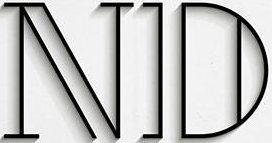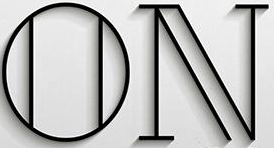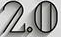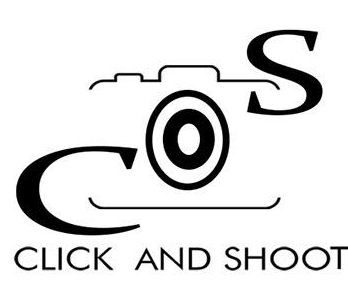What text is displayed in these images sequentially, separated by a semicolon? ND; ON; 2.0; COS 